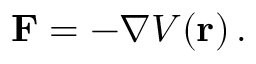Convert formula to latex. <formula><loc_0><loc_0><loc_500><loc_500>F = - \nabla V ( r ) \, .</formula> 